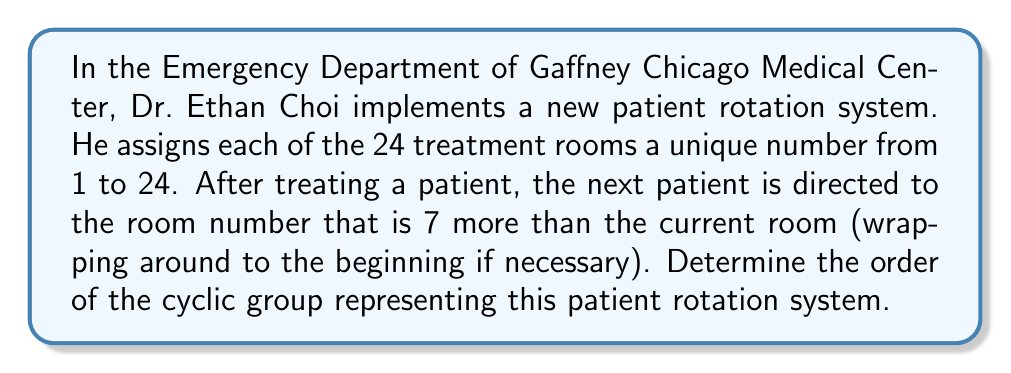Could you help me with this problem? To solve this problem, we need to understand the concept of cyclic groups and how to determine their order. Let's approach this step-by-step:

1) First, we need to identify the generator of the cyclic group. In this case, the generator is the operation of adding 7 to the room number (modulo 24).

2) Let's call this operation $a$. So, $a(x) = (x + 7) \mod 24$, where $x$ is the current room number.

3) To find the order of the group, we need to determine the smallest positive integer $n$ such that $a^n(x) = x$ for all $x$.

4) We can calculate this:
   $a^1(x) = (x + 7) \mod 24$
   $a^2(x) = (x + 14) \mod 24$
   $a^3(x) = (x + 21) \mod 24$
   $a^4(x) = (x + 28) \mod 24 = (x + 4) \mod 24$
   $a^5(x) = (x + 11) \mod 24$
   $a^6(x) = (x + 18) \mod 24$
   $a^7(x) = (x + 25) \mod 24 = (x + 1) \mod 24$
   $a^8(x) = (x + 8) \mod 24$

5) We can see that we don't return to $x$ until we've applied the operation 24 times:
   $a^{24}(x) = (x + 168) \mod 24 = x$

6) This is because $\gcd(7, 24) = 1$, meaning 7 and 24 are coprime. In a cyclic group of order $n$, if the generator $a$ is coprime to $n$, then the order of the group is $n$.

Therefore, the order of this cyclic group is 24.
Answer: The order of the cyclic group representing Dr. Ethan Choi's patient rotation system is 24. 